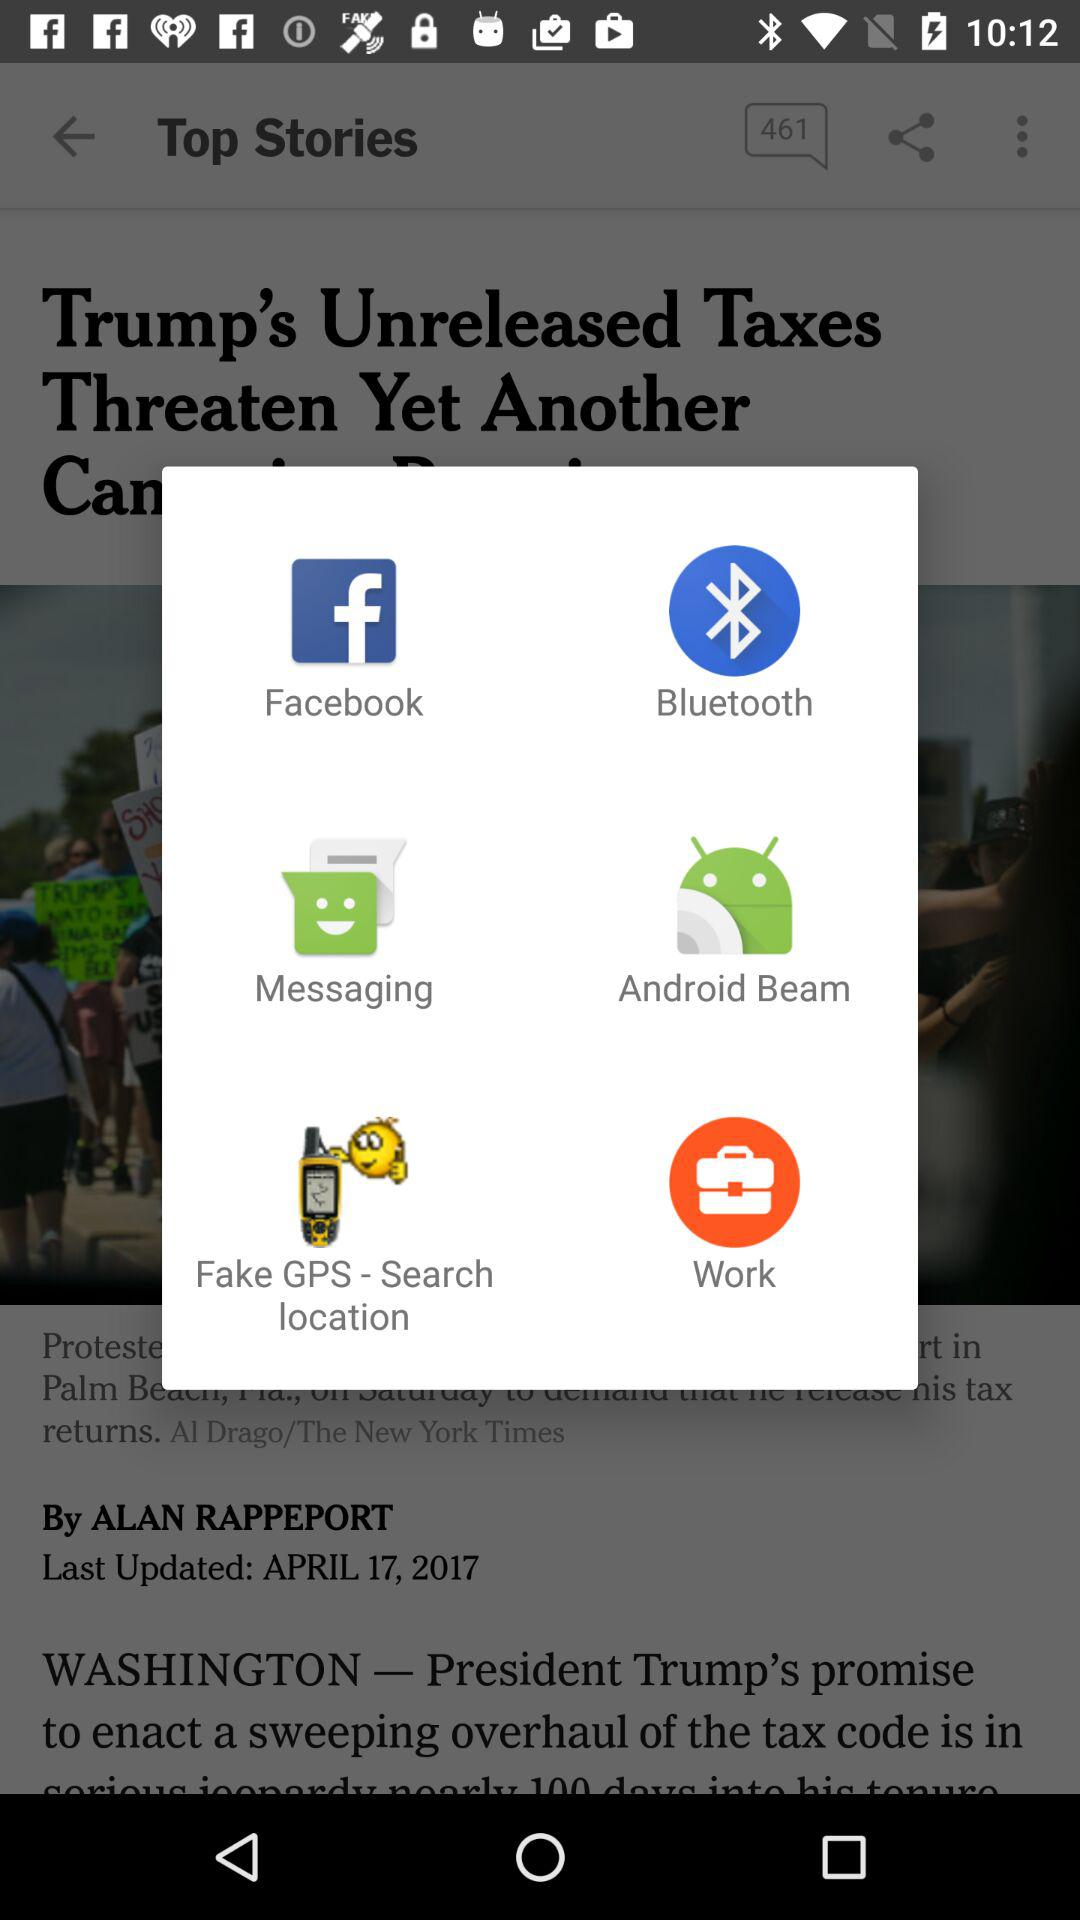What is the updated date of the article? The updated date of the article is April 17, 2017. 